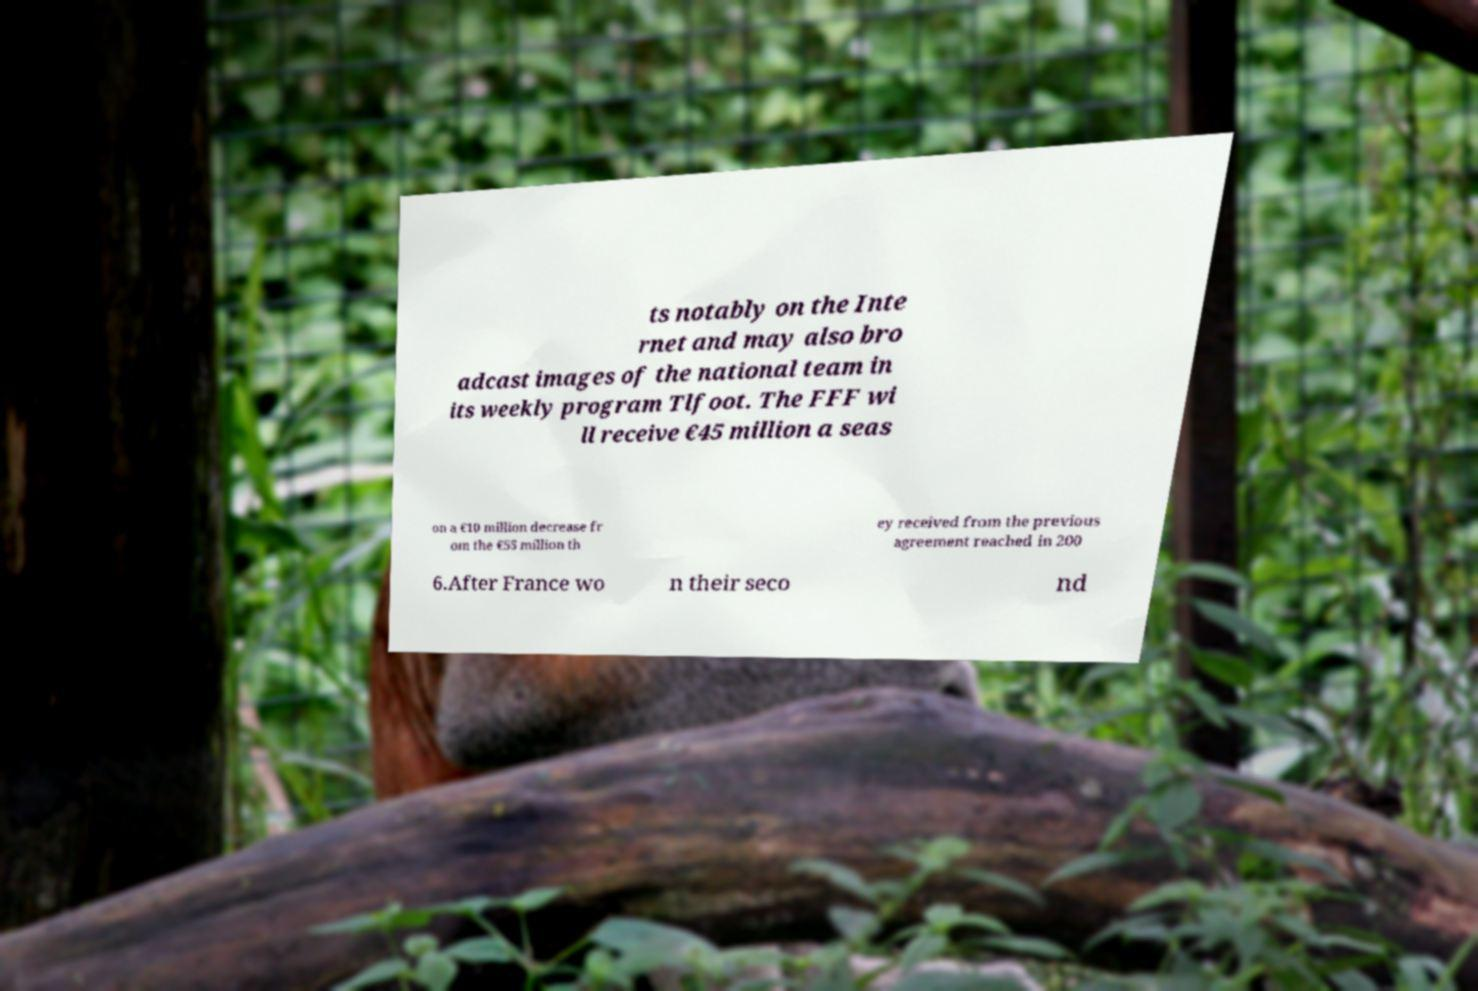What messages or text are displayed in this image? I need them in a readable, typed format. ts notably on the Inte rnet and may also bro adcast images of the national team in its weekly program Tlfoot. The FFF wi ll receive €45 million a seas on a €10 million decrease fr om the €55 million th ey received from the previous agreement reached in 200 6.After France wo n their seco nd 